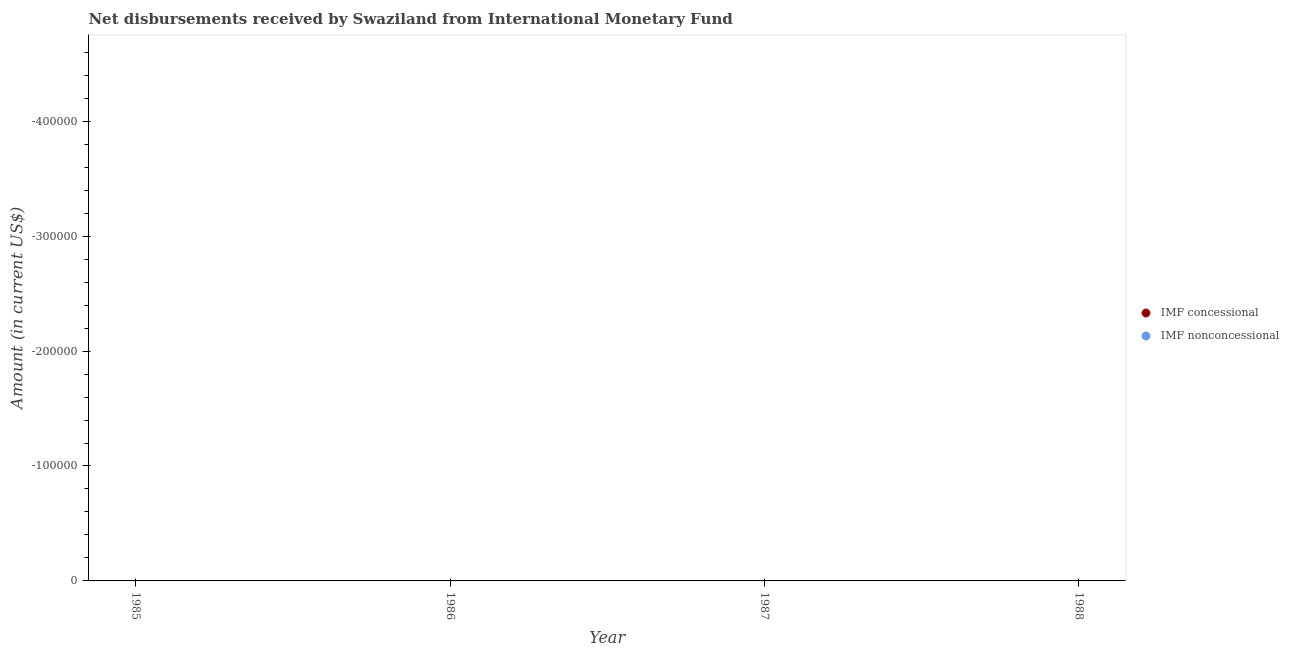How many different coloured dotlines are there?
Offer a very short reply. 0. Is the number of dotlines equal to the number of legend labels?
Your answer should be compact. No. Across all years, what is the minimum net concessional disbursements from imf?
Offer a very short reply. 0. What is the difference between the net concessional disbursements from imf in 1985 and the net non concessional disbursements from imf in 1988?
Offer a terse response. 0. What is the average net concessional disbursements from imf per year?
Your answer should be very brief. 0. In how many years, is the net concessional disbursements from imf greater than -220000 US$?
Keep it short and to the point. 0. In how many years, is the net concessional disbursements from imf greater than the average net concessional disbursements from imf taken over all years?
Your response must be concise. 0. Does the net concessional disbursements from imf monotonically increase over the years?
Offer a very short reply. No. How many dotlines are there?
Make the answer very short. 0. Are the values on the major ticks of Y-axis written in scientific E-notation?
Keep it short and to the point. No. Does the graph contain any zero values?
Provide a succinct answer. Yes. Does the graph contain grids?
Make the answer very short. No. Where does the legend appear in the graph?
Make the answer very short. Center right. How many legend labels are there?
Your response must be concise. 2. How are the legend labels stacked?
Keep it short and to the point. Vertical. What is the title of the graph?
Offer a terse response. Net disbursements received by Swaziland from International Monetary Fund. What is the label or title of the X-axis?
Give a very brief answer. Year. What is the label or title of the Y-axis?
Keep it short and to the point. Amount (in current US$). What is the Amount (in current US$) in IMF nonconcessional in 1985?
Provide a succinct answer. 0. What is the Amount (in current US$) of IMF nonconcessional in 1986?
Make the answer very short. 0. What is the Amount (in current US$) in IMF nonconcessional in 1987?
Provide a succinct answer. 0. What is the Amount (in current US$) in IMF concessional in 1988?
Give a very brief answer. 0. What is the average Amount (in current US$) in IMF concessional per year?
Offer a terse response. 0. What is the average Amount (in current US$) of IMF nonconcessional per year?
Give a very brief answer. 0. 